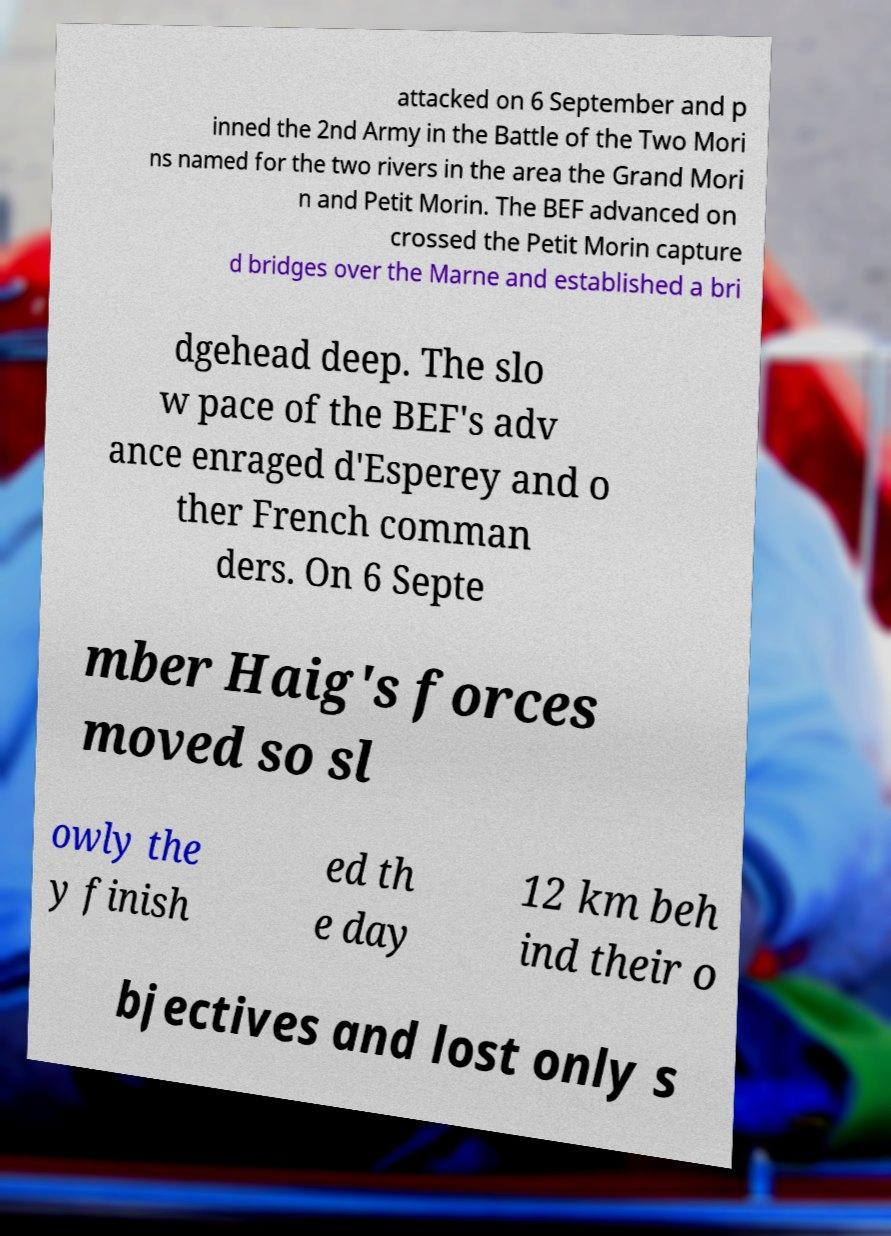Could you extract and type out the text from this image? attacked on 6 September and p inned the 2nd Army in the Battle of the Two Mori ns named for the two rivers in the area the Grand Mori n and Petit Morin. The BEF advanced on crossed the Petit Morin capture d bridges over the Marne and established a bri dgehead deep. The slo w pace of the BEF's adv ance enraged d'Esperey and o ther French comman ders. On 6 Septe mber Haig's forces moved so sl owly the y finish ed th e day 12 km beh ind their o bjectives and lost only s 